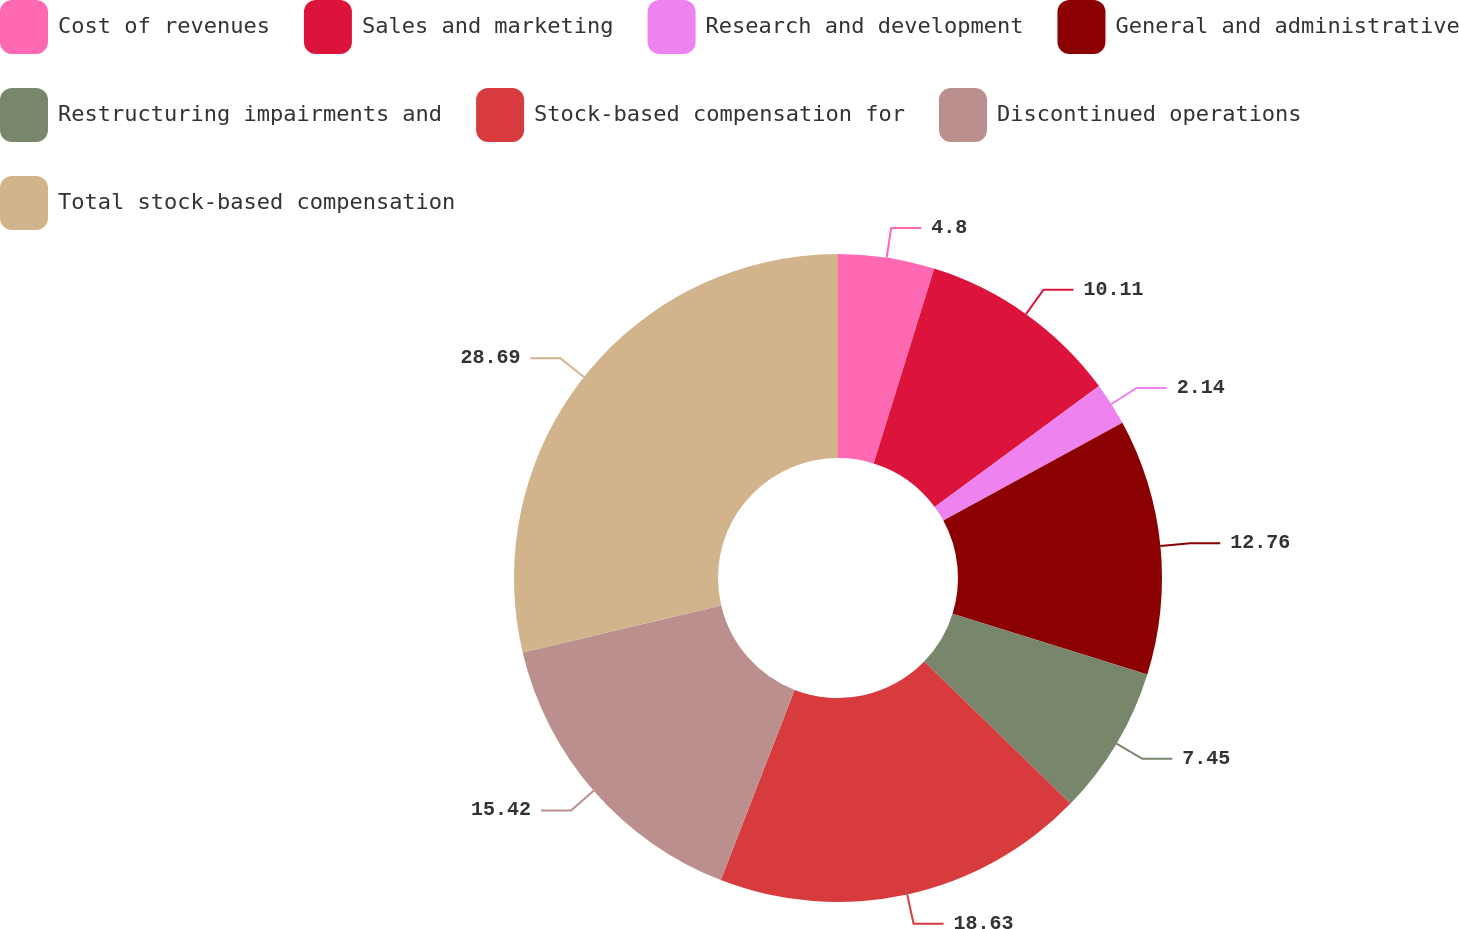Convert chart. <chart><loc_0><loc_0><loc_500><loc_500><pie_chart><fcel>Cost of revenues<fcel>Sales and marketing<fcel>Research and development<fcel>General and administrative<fcel>Restructuring impairments and<fcel>Stock-based compensation for<fcel>Discontinued operations<fcel>Total stock-based compensation<nl><fcel>4.8%<fcel>10.11%<fcel>2.14%<fcel>12.76%<fcel>7.45%<fcel>18.63%<fcel>15.42%<fcel>28.69%<nl></chart> 